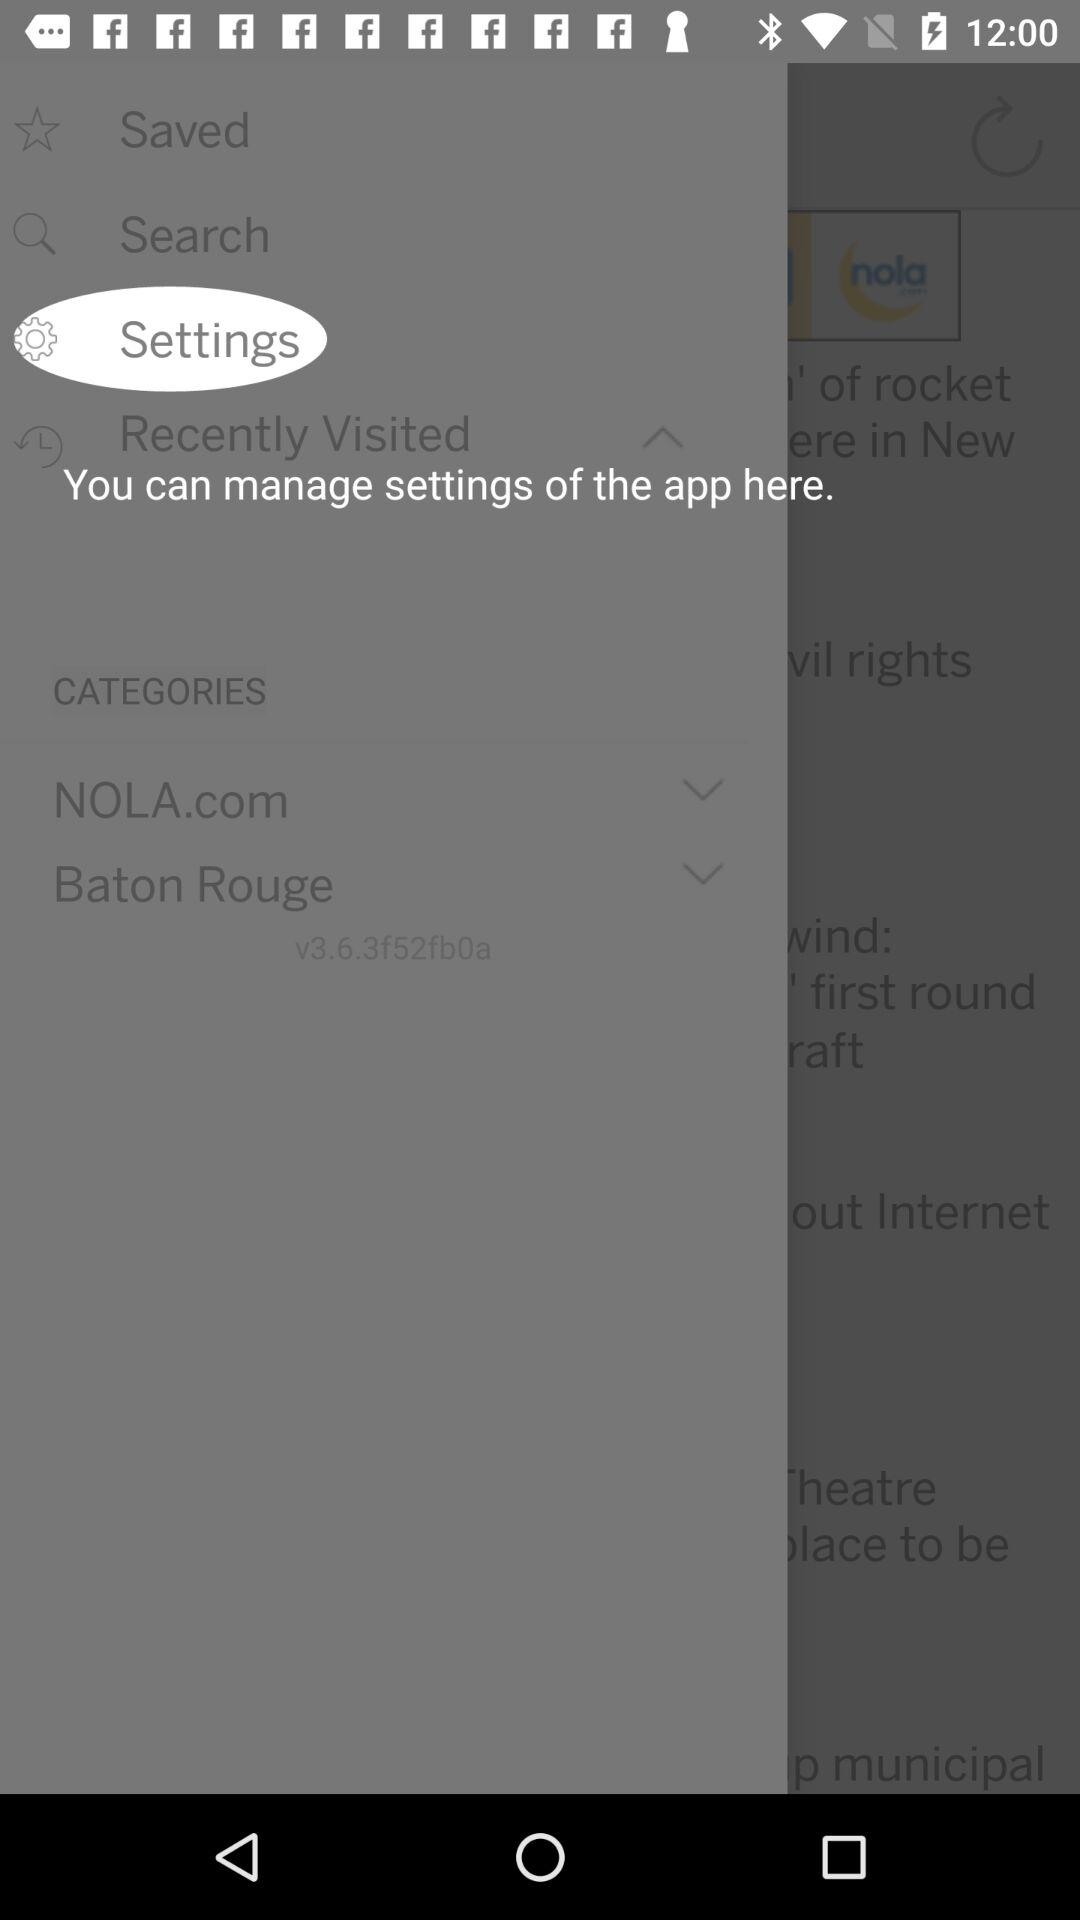What is the version? The version is v3.6.3f52fb0a. 